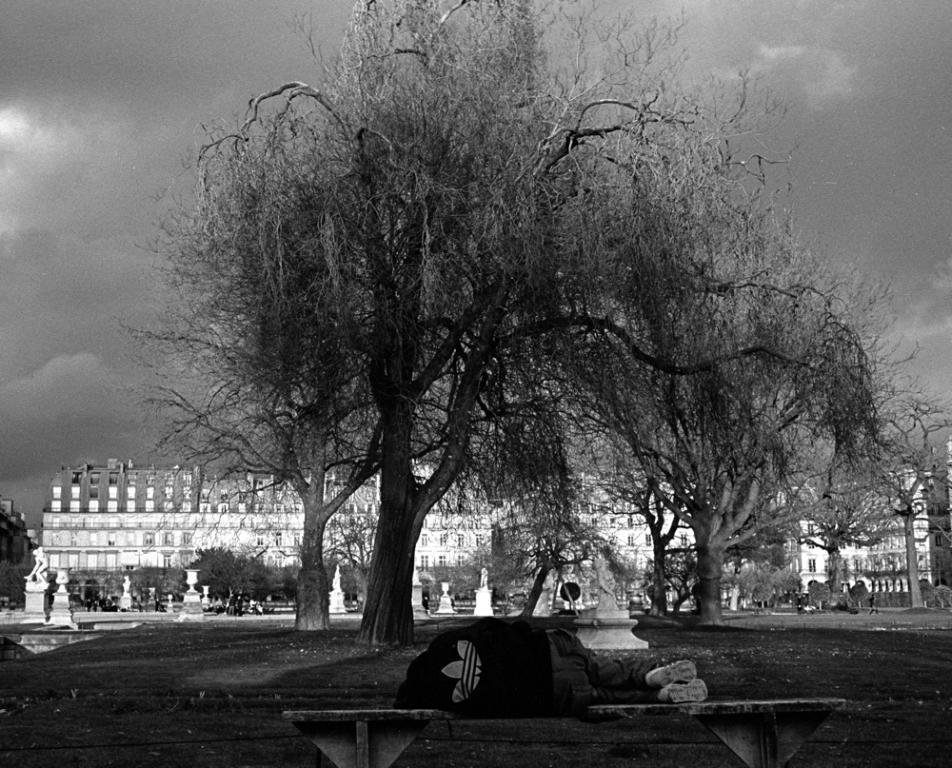What is the person in the image doing? The person is lying on a bench in the image. What type of natural elements can be seen in the image? There are trees in the image. What type of man-made structures are visible in the image? There are buildings in the image. How would you describe the weather in the image? The sky is cloudy in the image. Is there an umbrella being used by the person in the image? There is no umbrella present in the image. What type of event is taking place in the image? There is no event depicted in the image; it simply shows a person lying on a bench with trees, buildings, and a cloudy sky in the background. 